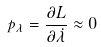<formula> <loc_0><loc_0><loc_500><loc_500>p _ { \lambda } = \frac { \partial L } { \partial \dot { \lambda } } \approx 0</formula> 